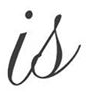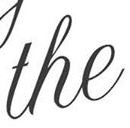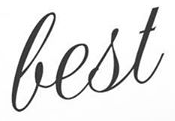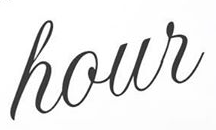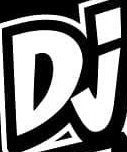Identify the words shown in these images in order, separated by a semicolon. is; the; best; hour; Dj 